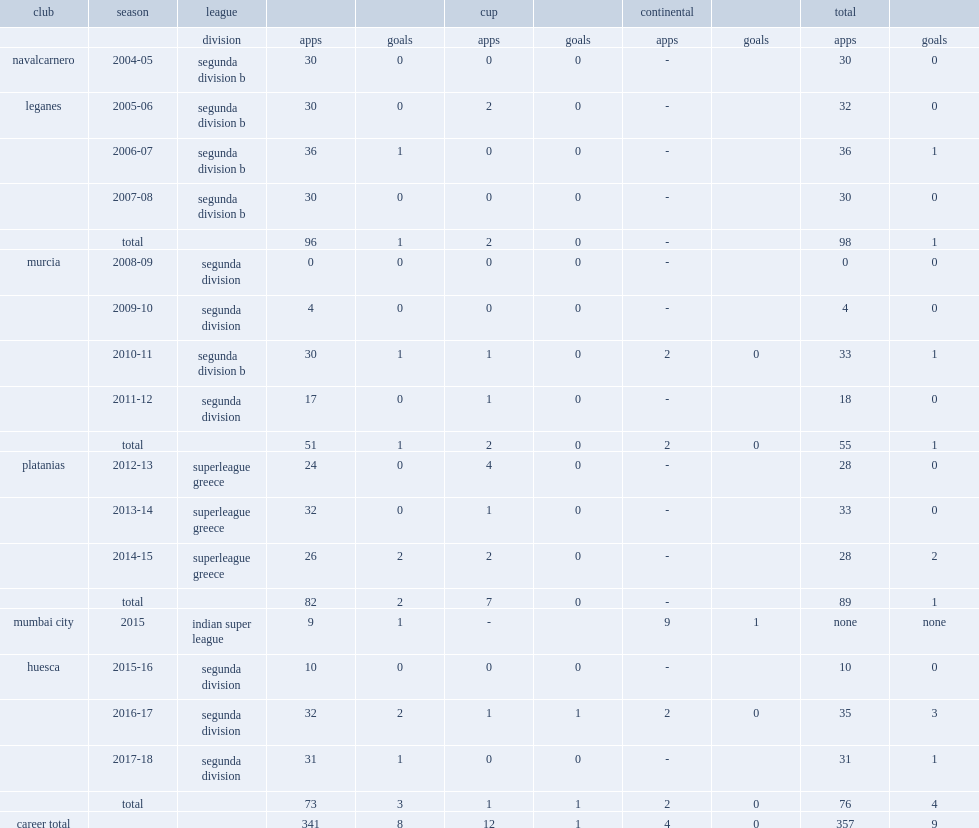Which league did juan aguilera sign for club mumbai city in 2015? Indian super league. 